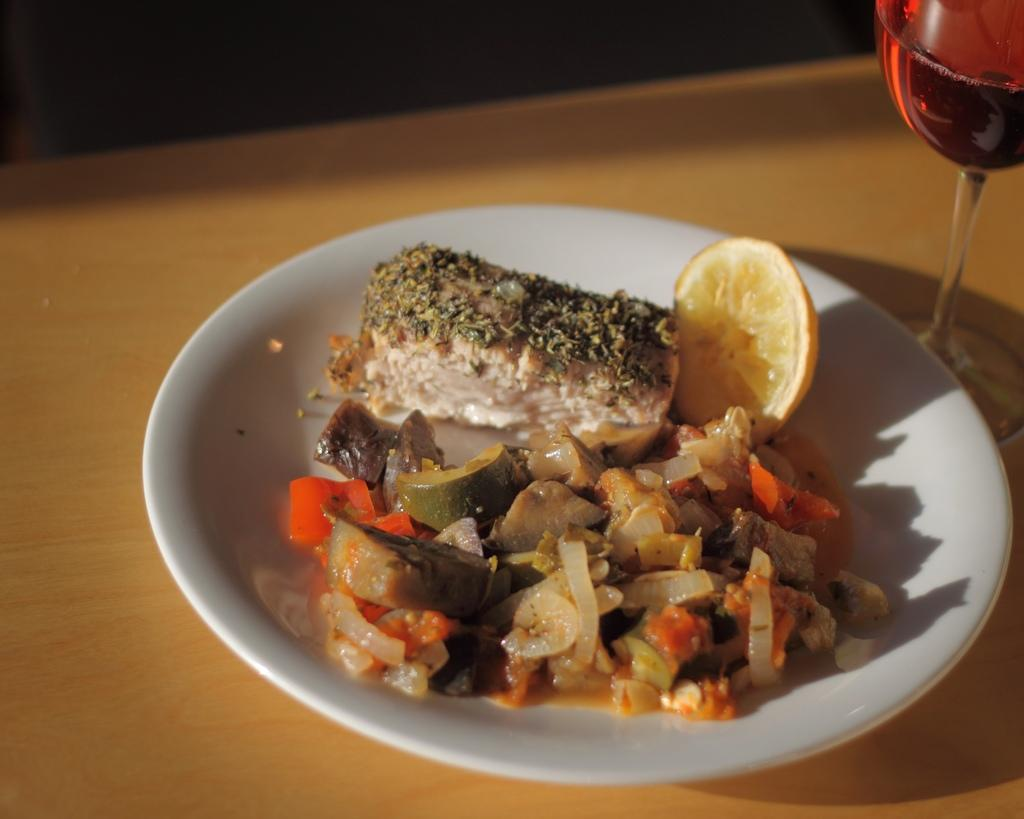What is on the plate that is visible in the image? There is there any food in the image? What other items can be seen on the table in the image? There is a wine glass on the table in the image. What street is visible in the image? There is no street visible in the image; it appears to be a table setting with food and a wine glass. 